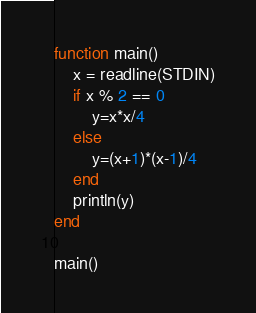<code> <loc_0><loc_0><loc_500><loc_500><_Julia_>function main()
	x = readline(STDIN)
	if x % 2 == 0
		y=x*x/4
	else
		y=(x+1)*(x-1)/4
	end
	println(y)
end

main()</code> 